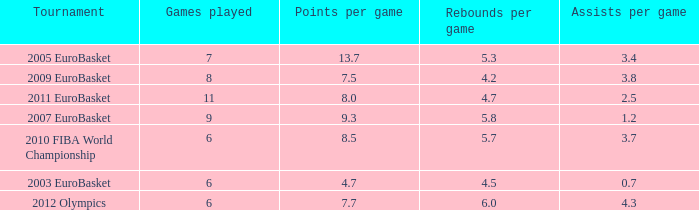How may assists per game have 7.7 points per game? 4.3. Can you parse all the data within this table? {'header': ['Tournament', 'Games played', 'Points per game', 'Rebounds per game', 'Assists per game'], 'rows': [['2005 EuroBasket', '7', '13.7', '5.3', '3.4'], ['2009 EuroBasket', '8', '7.5', '4.2', '3.8'], ['2011 EuroBasket', '11', '8.0', '4.7', '2.5'], ['2007 EuroBasket', '9', '9.3', '5.8', '1.2'], ['2010 FIBA World Championship', '6', '8.5', '5.7', '3.7'], ['2003 EuroBasket', '6', '4.7', '4.5', '0.7'], ['2012 Olympics', '6', '7.7', '6.0', '4.3']]} 